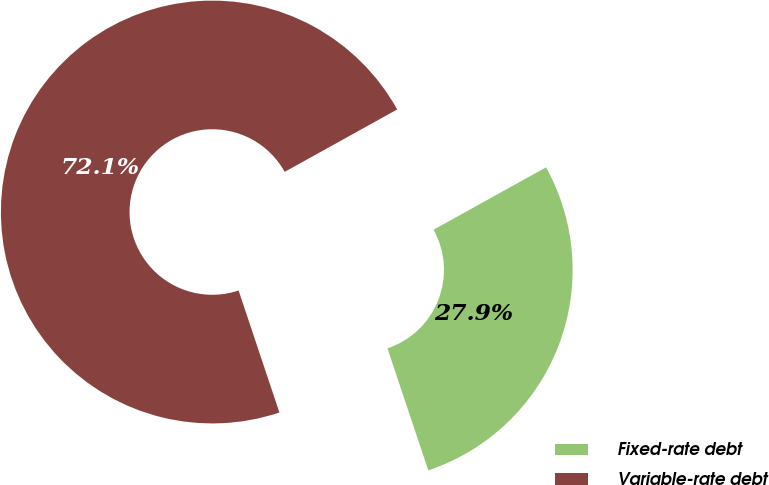Convert chart. <chart><loc_0><loc_0><loc_500><loc_500><pie_chart><fcel>Fixed-rate debt<fcel>Variable-rate debt<nl><fcel>27.92%<fcel>72.08%<nl></chart> 